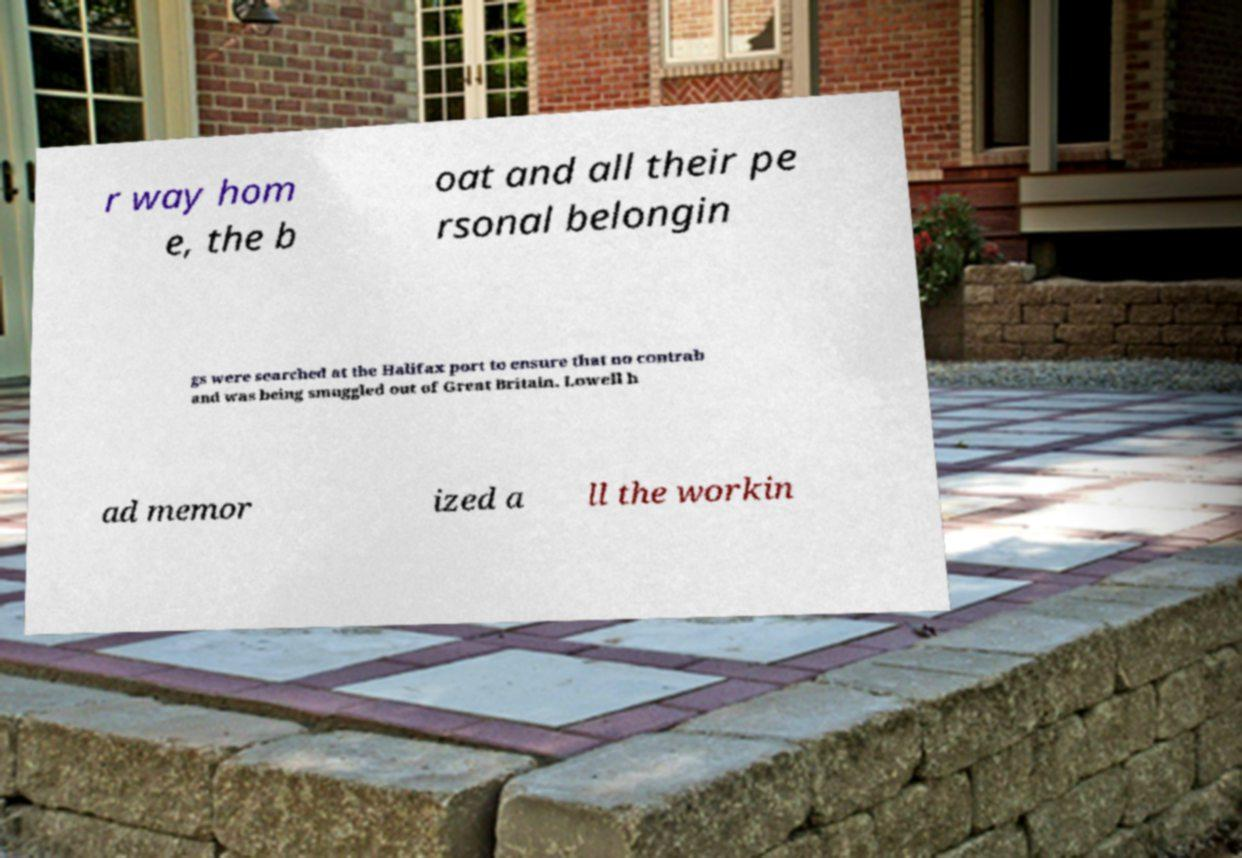Can you read and provide the text displayed in the image?This photo seems to have some interesting text. Can you extract and type it out for me? r way hom e, the b oat and all their pe rsonal belongin gs were searched at the Halifax port to ensure that no contrab and was being smuggled out of Great Britain. Lowell h ad memor ized a ll the workin 